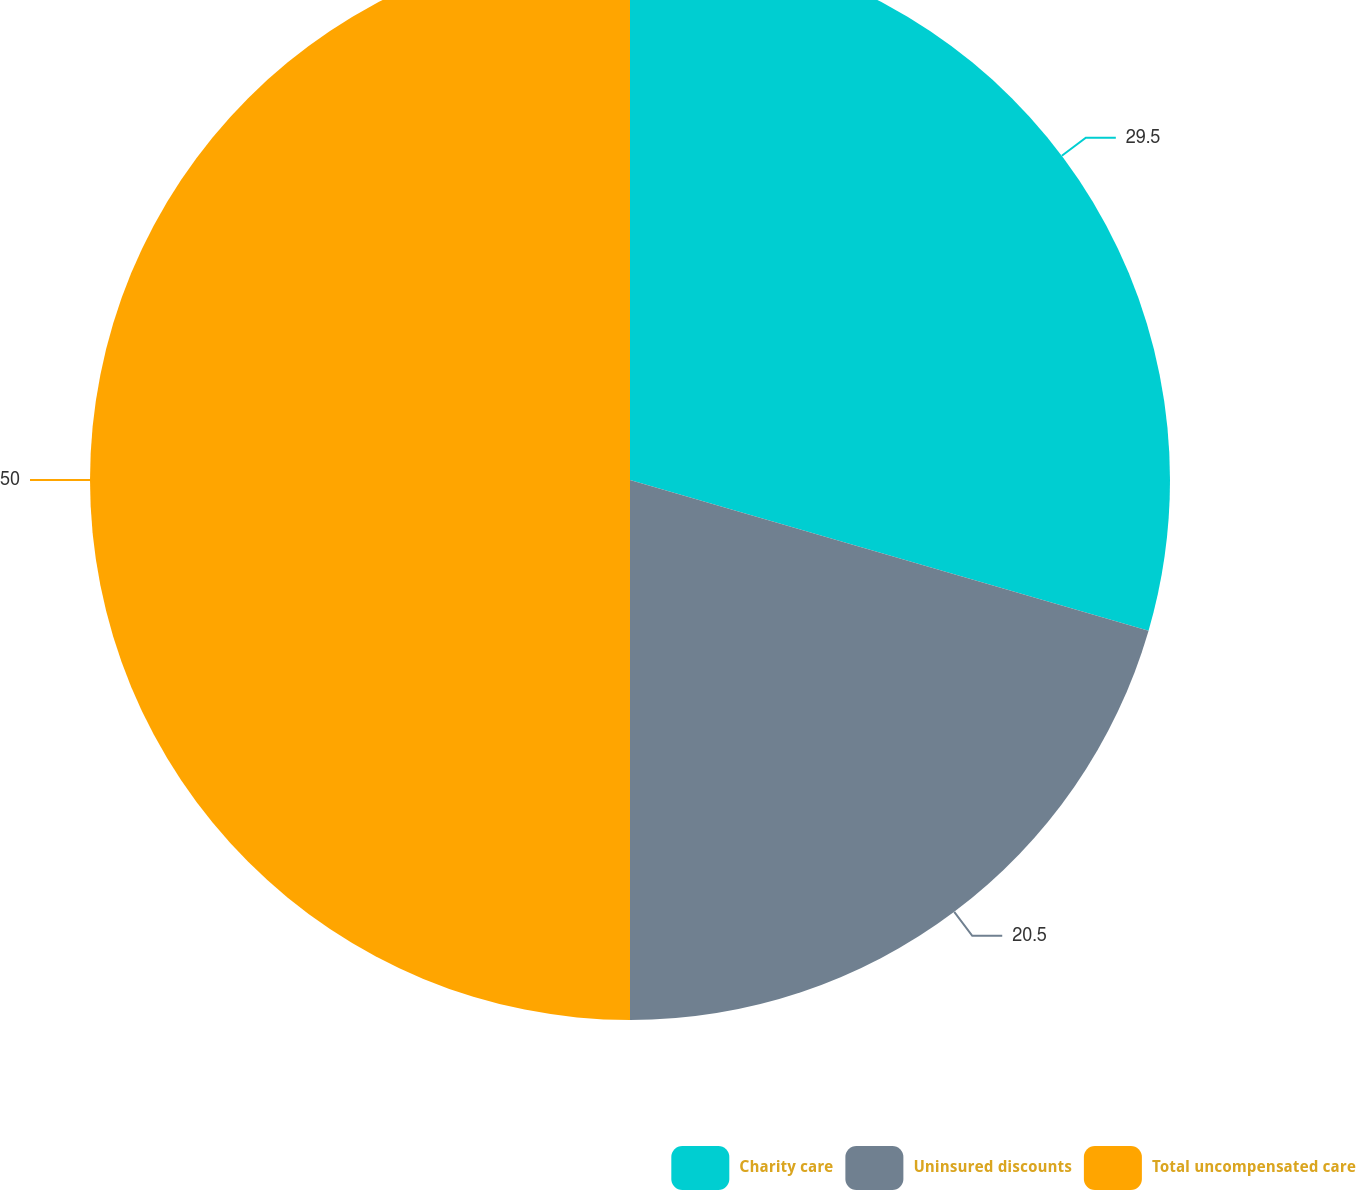<chart> <loc_0><loc_0><loc_500><loc_500><pie_chart><fcel>Charity care<fcel>Uninsured discounts<fcel>Total uncompensated care<nl><fcel>29.5%<fcel>20.5%<fcel>50.0%<nl></chart> 